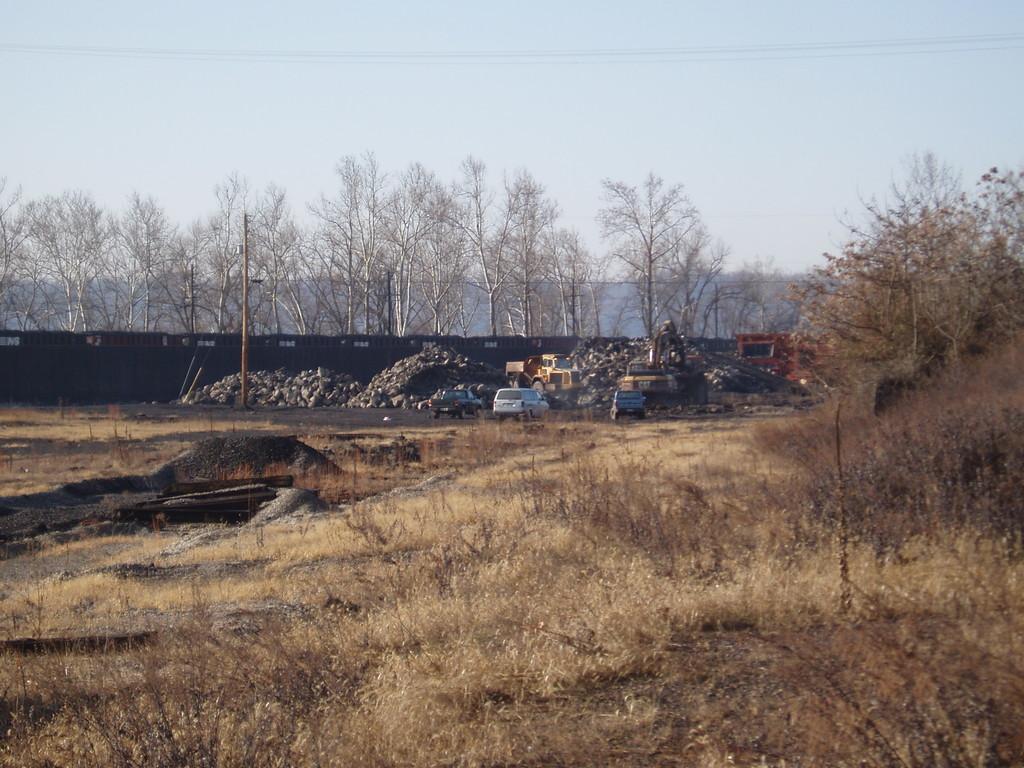Can you describe this image briefly? In this picture we can see vehicles on the ground, pole, fence, trees and in the background we can see sky. 